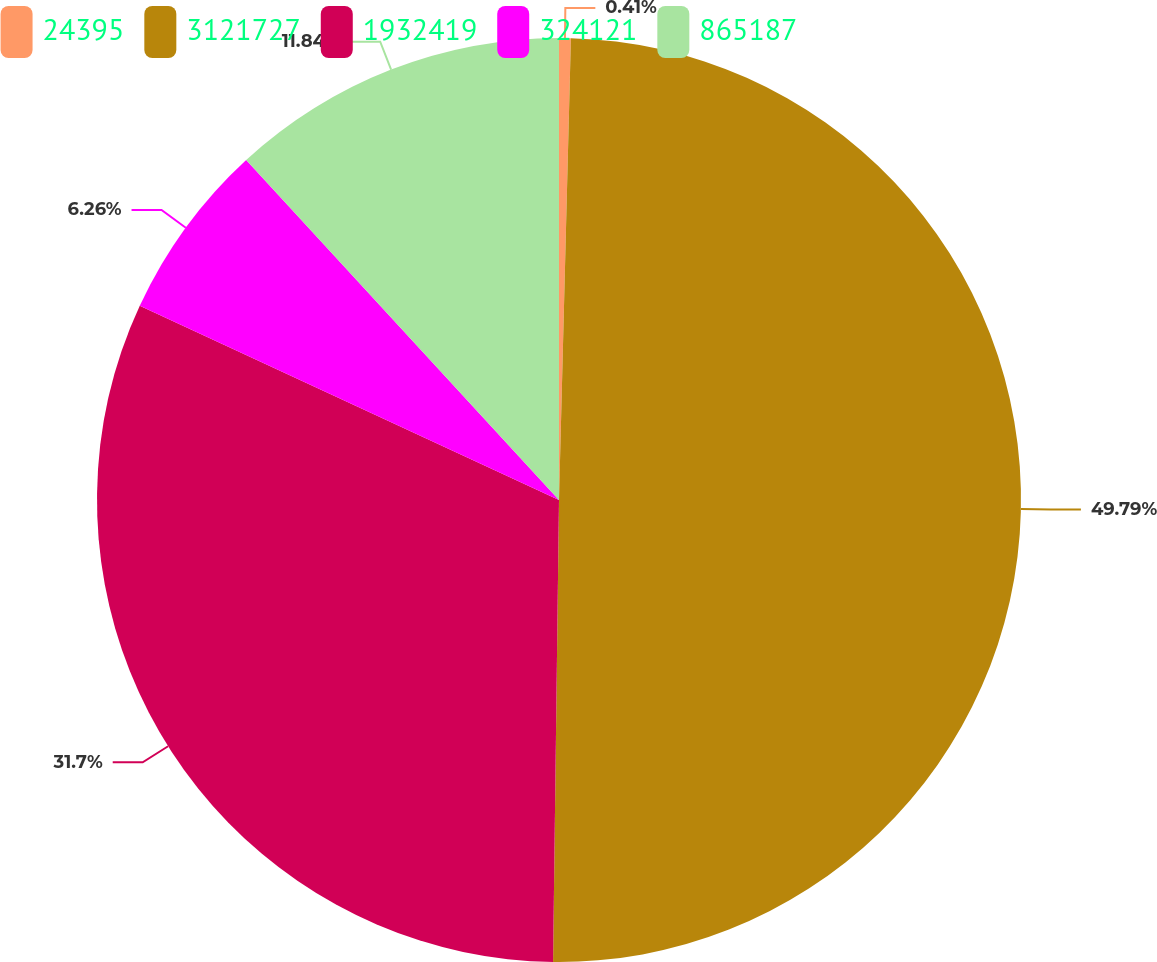<chart> <loc_0><loc_0><loc_500><loc_500><pie_chart><fcel>24395<fcel>3121727<fcel>1932419<fcel>324121<fcel>865187<nl><fcel>0.41%<fcel>49.8%<fcel>31.7%<fcel>6.26%<fcel>11.84%<nl></chart> 